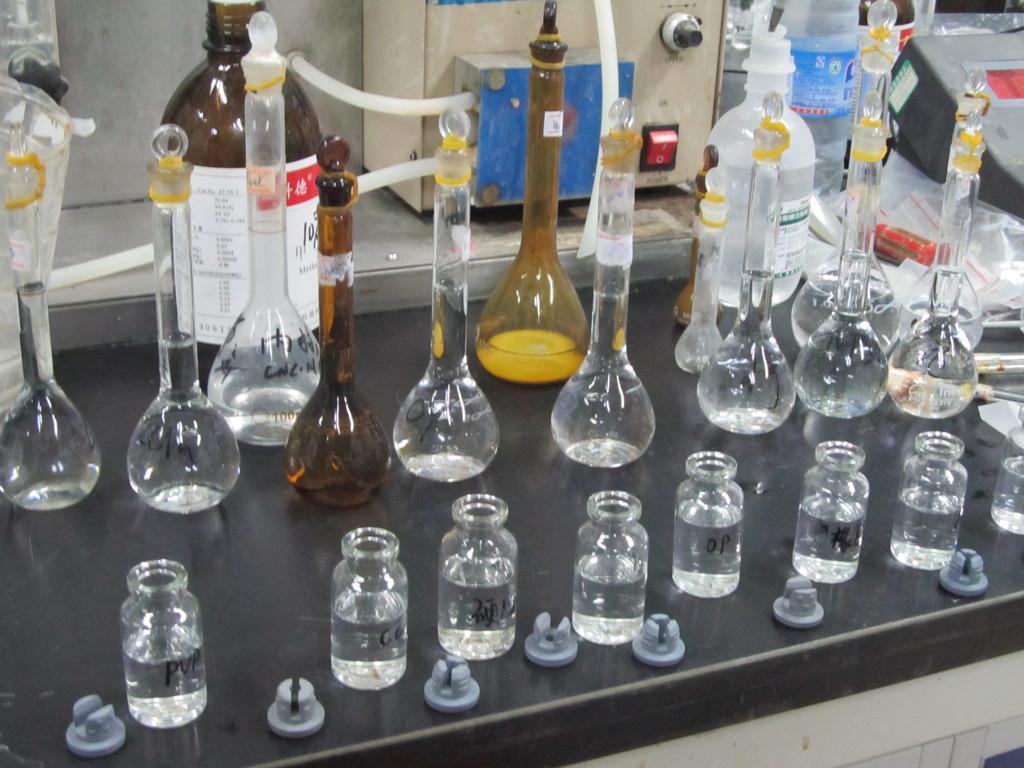Please provide a concise description of this image. Here we can see a chemistry lab and there are bottles and jars and containers present in it on a table 